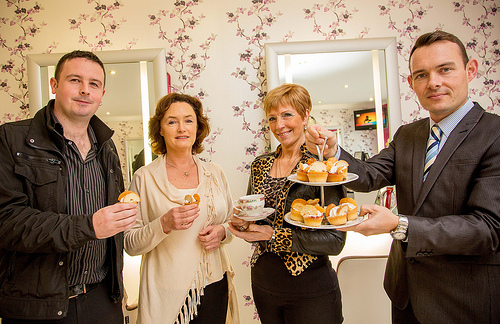<image>
Is the man behind the woman? No. The man is not behind the woman. From this viewpoint, the man appears to be positioned elsewhere in the scene. Is there a man next to the woman? Yes. The man is positioned adjacent to the woman, located nearby in the same general area. Is the women next to the mirror? No. The women is not positioned next to the mirror. They are located in different areas of the scene. 